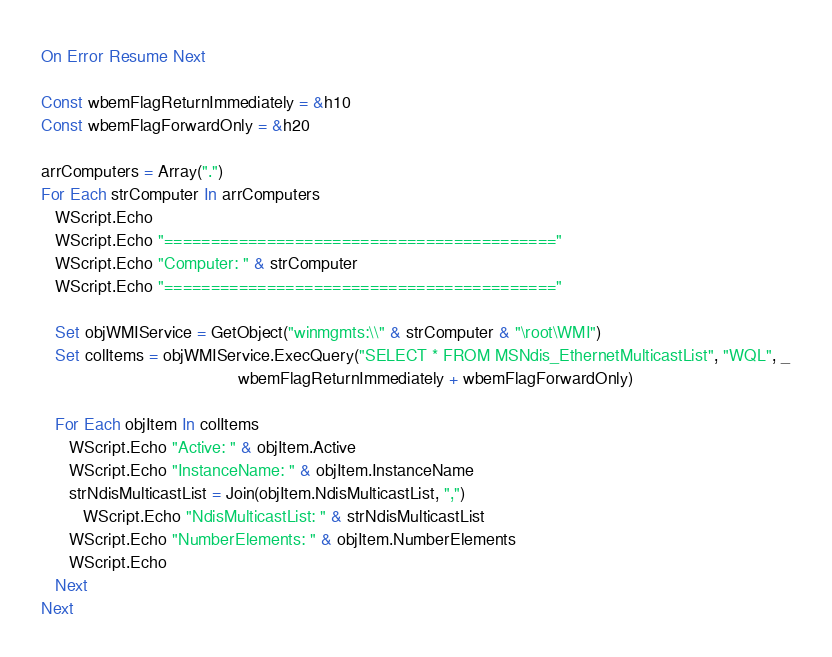<code> <loc_0><loc_0><loc_500><loc_500><_VisualBasic_>On Error Resume Next

Const wbemFlagReturnImmediately = &h10
Const wbemFlagForwardOnly = &h20

arrComputers = Array(".")
For Each strComputer In arrComputers
   WScript.Echo
   WScript.Echo "=========================================="
   WScript.Echo "Computer: " & strComputer
   WScript.Echo "=========================================="

   Set objWMIService = GetObject("winmgmts:\\" & strComputer & "\root\WMI")
   Set colItems = objWMIService.ExecQuery("SELECT * FROM MSNdis_EthernetMulticastList", "WQL", _
                                          wbemFlagReturnImmediately + wbemFlagForwardOnly)

   For Each objItem In colItems
      WScript.Echo "Active: " & objItem.Active
      WScript.Echo "InstanceName: " & objItem.InstanceName
      strNdisMulticastList = Join(objItem.NdisMulticastList, ",")
         WScript.Echo "NdisMulticastList: " & strNdisMulticastList
      WScript.Echo "NumberElements: " & objItem.NumberElements
      WScript.Echo
   Next
Next

</code> 